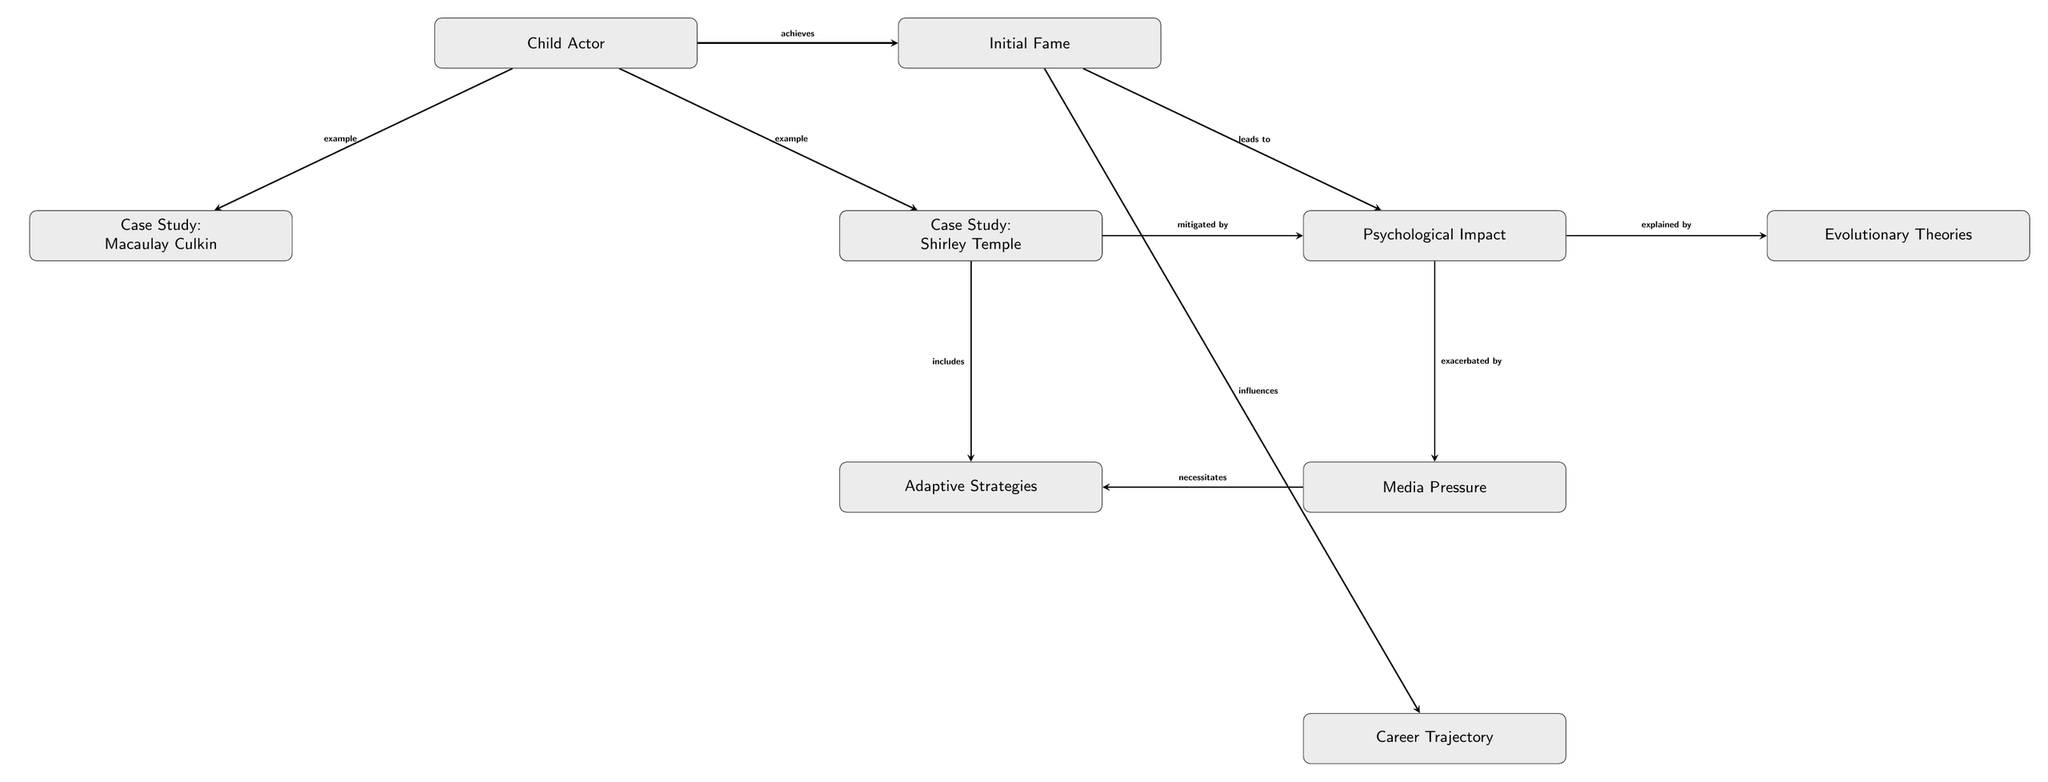What is the first node in the diagram? The first node is labeled "Child Actor." It is positioned at the top of the diagram, indicating that it is the starting point of the flow.
Answer: Child Actor How many case studies are included in the diagram? The diagram includes two case studies, represented by the nodes "Case Study: Macaulay Culkin" and "Case Study: Shirley Temple." Both are situated below the "Child Actor" node.
Answer: 2 What does initial fame lead to? Initial fame leads to the "Psychological Impact" node, which is directly connected by an edge indicating that it is a consequence of the fame achieved.
Answer: Psychological Impact Which node mitigates the psychological impact? The node that mitigates the psychological impact is "Family Support," which is connected to the "Psychological Impact" indicating a buffering effect.
Answer: Family Support What is necessitated by media pressure? The node "Adaptive Strategies" is necessitated by media pressure, as indicated by the connection showing that the pressures from media require the development of coping strategies.
Answer: Adaptive Strategies Explain the relationship between psychological impact and evolutionary theories. The psychological impact is explained by the node "Evolutionary Theories," demonstrating that there is a theoretical framework that seeks to clarify why the psychological effects occur in child actors due to their fame.
Answer: explained by What influences career trajectory? The "Initial Fame" node influences the "Career Trajectory" node, indicating that the degree of fame attained by the child actor has a direct impact on how their career develops afterwards.
Answer: influences Which two nodes are directly connected to family support? The nodes directly connected to "Family Support" are "Psychological Impact" (by mitigating it) and "Adaptive Strategies" (by including it). These connections signify the supportive functions of family in the context of the diagram.
Answer: Psychological Impact and Adaptive Strategies What does media pressure exacerbate? Media pressure exacerbates the "Psychological Impact," as suggested by the connection that indicates that media stressors can intensify the psychological consequences faced by child actors.
Answer: Psychological Impact 